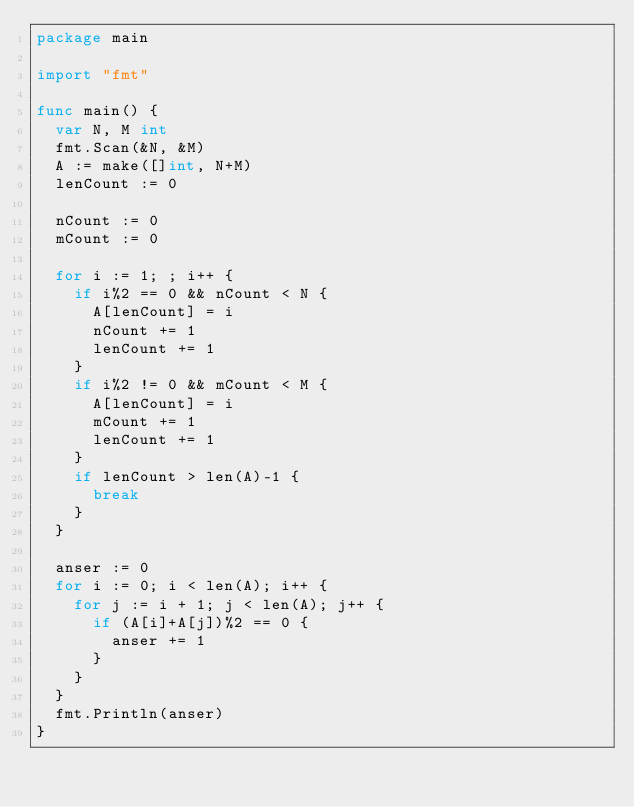<code> <loc_0><loc_0><loc_500><loc_500><_Go_>package main

import "fmt"

func main() {
  var N, M int
  fmt.Scan(&N, &M)
  A := make([]int, N+M)
  lenCount := 0

  nCount := 0
  mCount := 0

  for i := 1; ; i++ {
    if i%2 == 0 && nCount < N {
      A[lenCount] = i
      nCount += 1
      lenCount += 1
    }
    if i%2 != 0 && mCount < M {
      A[lenCount] = i
      mCount += 1
      lenCount += 1
    }
    if lenCount > len(A)-1 {
      break
    }
  }

  anser := 0
  for i := 0; i < len(A); i++ {
    for j := i + 1; j < len(A); j++ {
      if (A[i]+A[j])%2 == 0 {
        anser += 1
      }
    }
  }
  fmt.Println(anser)
}</code> 